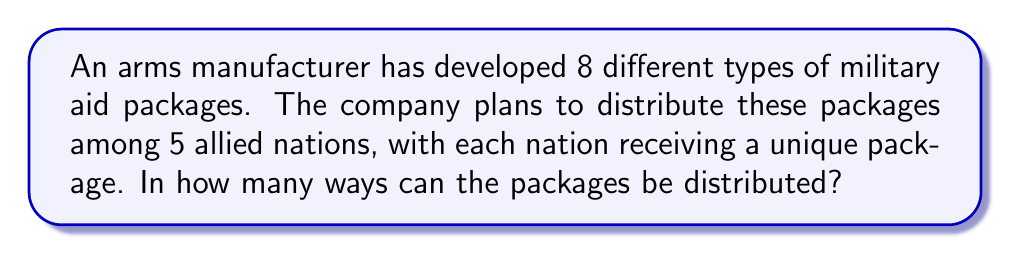Provide a solution to this math problem. To solve this problem, we need to use the concept of permutations. Here's a step-by-step explanation:

1) We have 8 different types of packages and need to choose 5 of them to distribute.

2) The order of distribution matters, as each nation receives a specific package.

3) This scenario is a permutation without repetition, as each package can only be given once.

4) The formula for permutations without repetition is:

   $$P(n,r) = \frac{n!}{(n-r)!}$$

   Where $n$ is the total number of items to choose from, and $r$ is the number of items being chosen.

5) In this case, $n = 8$ (total packages) and $r = 5$ (allied nations).

6) Plugging these values into the formula:

   $$P(8,5) = \frac{8!}{(8-5)!} = \frac{8!}{3!}$$

7) Expanding this:

   $$\frac{8 \times 7 \times 6 \times 5 \times 4 \times 3!}{3!}$$

8) The $3!$ cancels out in the numerator and denominator:

   $$8 \times 7 \times 6 \times 5 \times 4 = 6720$$

Therefore, there are 6720 unique ways to distribute the military aid packages to the allied nations.
Answer: 6720 